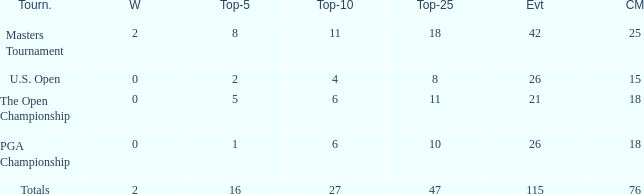How many average cuts made when 11 is the Top-10? 25.0. 